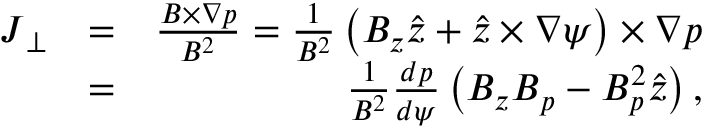Convert formula to latex. <formula><loc_0><loc_0><loc_500><loc_500>\begin{array} { r l r } { J _ { \perp } } & { = } & { \frac { B \times \nabla p } { B ^ { 2 } } = \frac { 1 } { B ^ { 2 } } \left ( B _ { z } \hat { z } + \hat { z } \times \nabla \psi \right ) \times \nabla p } \\ & { = } & { \frac { 1 } { B ^ { 2 } } \frac { d p } { d \psi } \left ( B _ { z } B _ { p } - B _ { p } ^ { 2 } \hat { z } \right ) , } \end{array}</formula> 